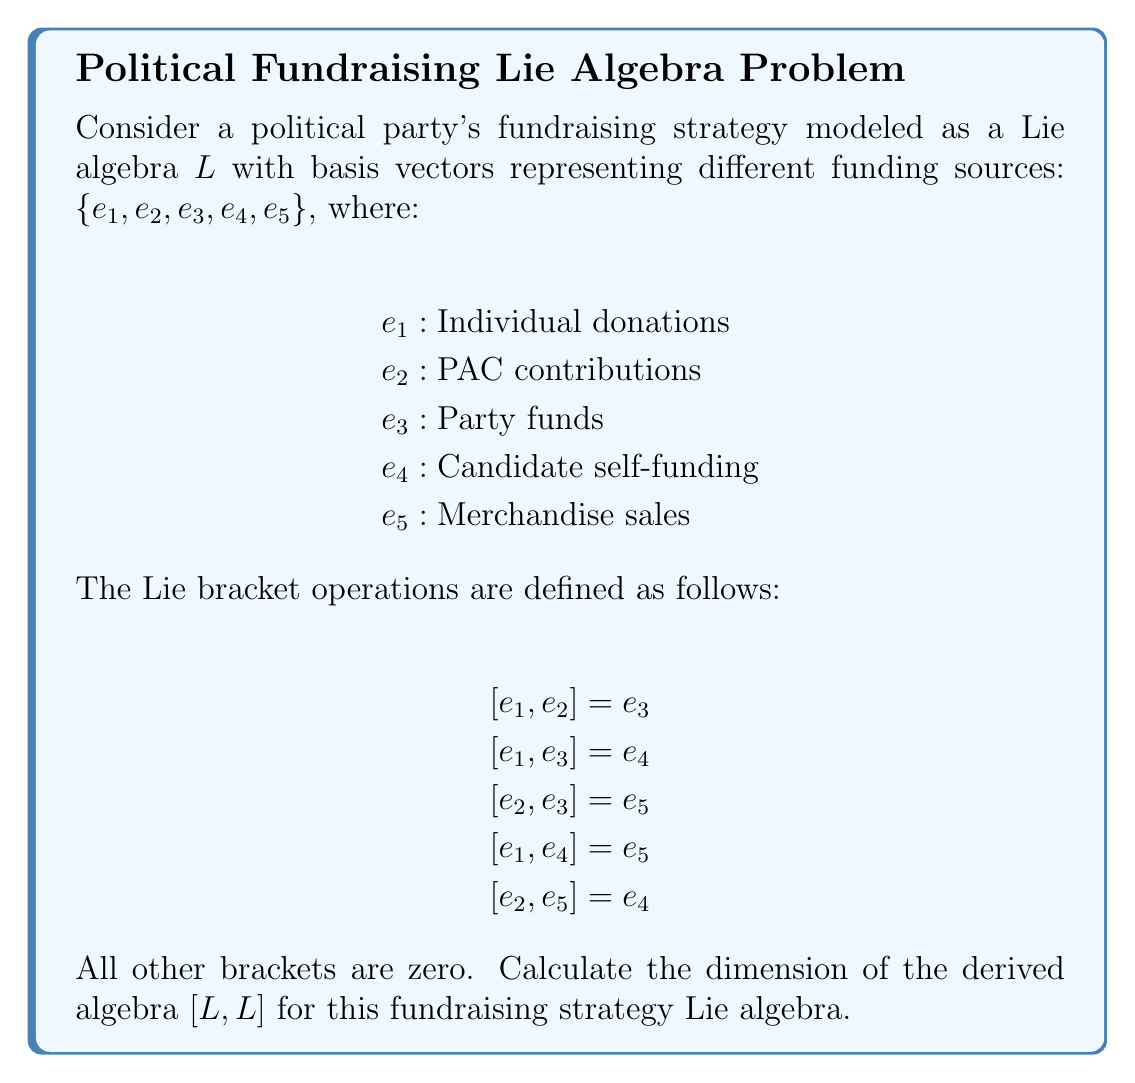Solve this math problem. To solve this problem, we need to follow these steps:

1) First, recall that the derived algebra $[L,L]$ is the subalgebra generated by all Lie brackets $[x,y]$ where $x,y \in L$.

2) From the given Lie bracket operations, we can see that $[L,L]$ is spanned by $e_3$, $e_4$, and $e_5$. This is because these are the only basis vectors that appear as results of the non-zero Lie brackets.

3) To determine the dimension of $[L,L]$, we need to check if these spanning elements are linearly independent.

4) Let's assume there's a linear combination that equals zero:

   $ae_3 + be_4 + ce_5 = 0$

5) For this to be true for all possible values, we must have $a = b = c = 0$. This is because $e_3$, $e_4$, and $e_5$ are basis vectors of the original algebra and are therefore linearly independent.

6) Since $e_3$, $e_4$, and $e_5$ are linearly independent, they form a basis for $[L,L]$.

7) The dimension of a vector space is equal to the number of vectors in its basis.

Therefore, the dimension of $[L,L]$ is 3.
Answer: The dimension of the derived algebra $[L,L]$ is 3. 